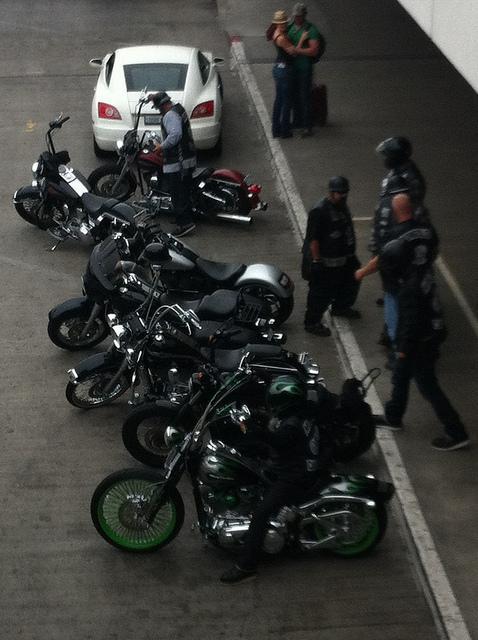How many motorcycles are in the photo?
Give a very brief answer. 6. How many motorbikes?
Give a very brief answer. 6. How many motorcycles can you see?
Give a very brief answer. 7. How many people are there?
Give a very brief answer. 7. 